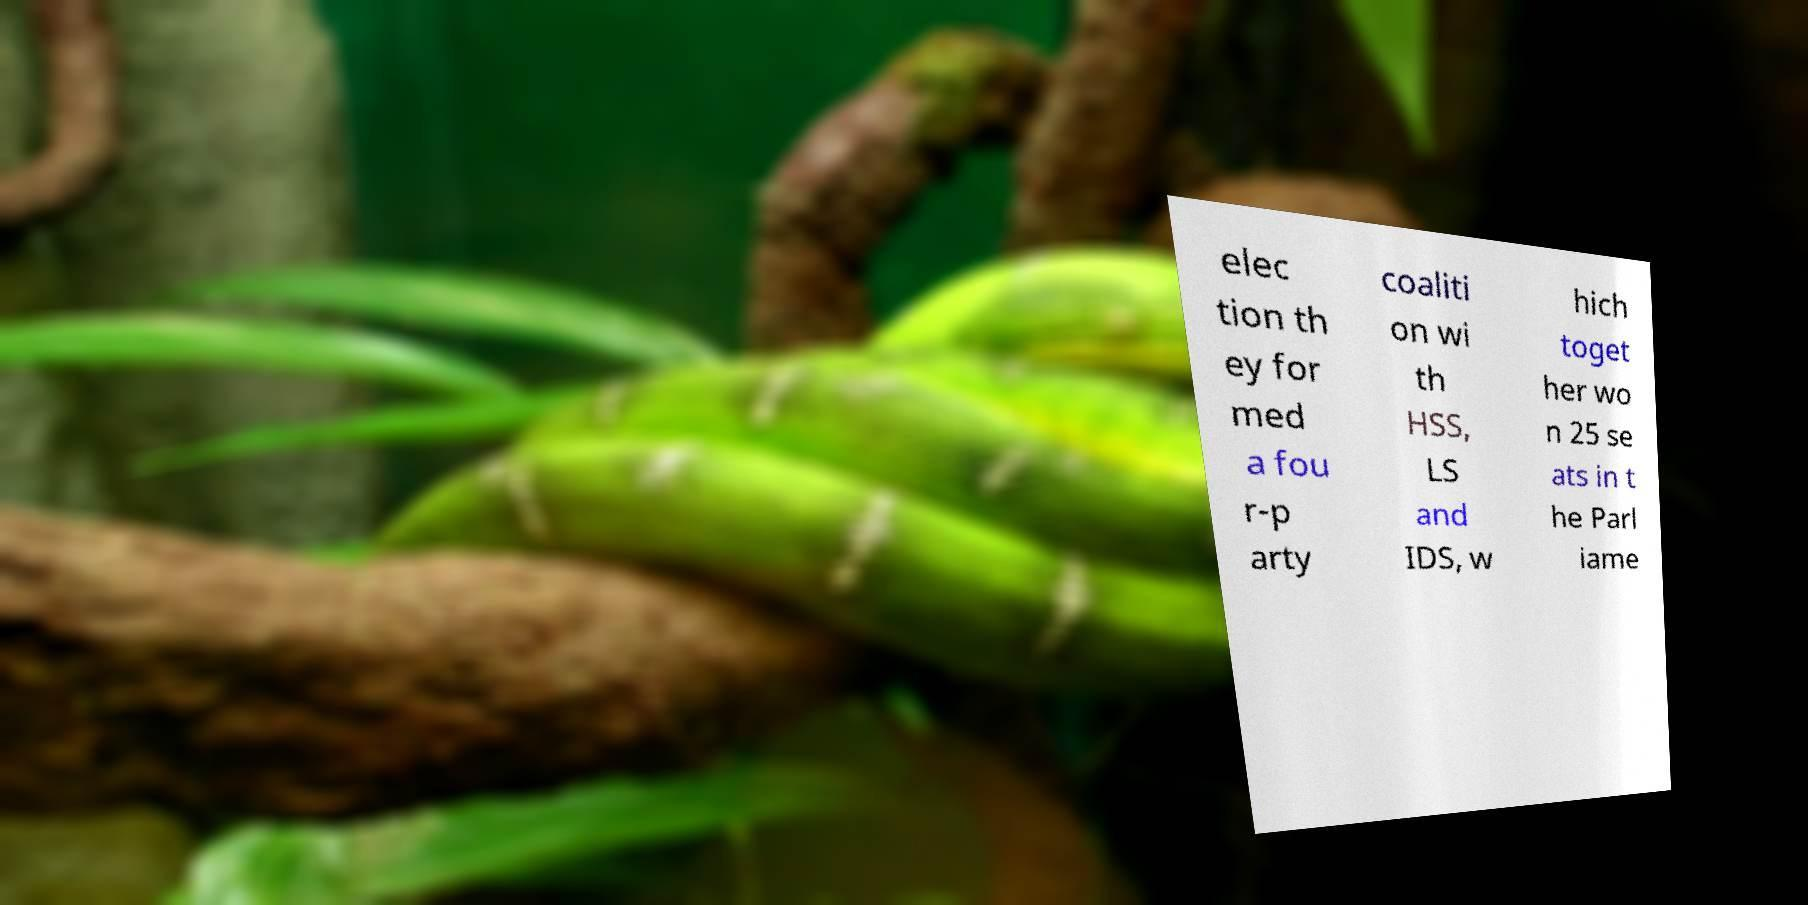Can you read and provide the text displayed in the image?This photo seems to have some interesting text. Can you extract and type it out for me? elec tion th ey for med a fou r-p arty coaliti on wi th HSS, LS and IDS, w hich toget her wo n 25 se ats in t he Parl iame 